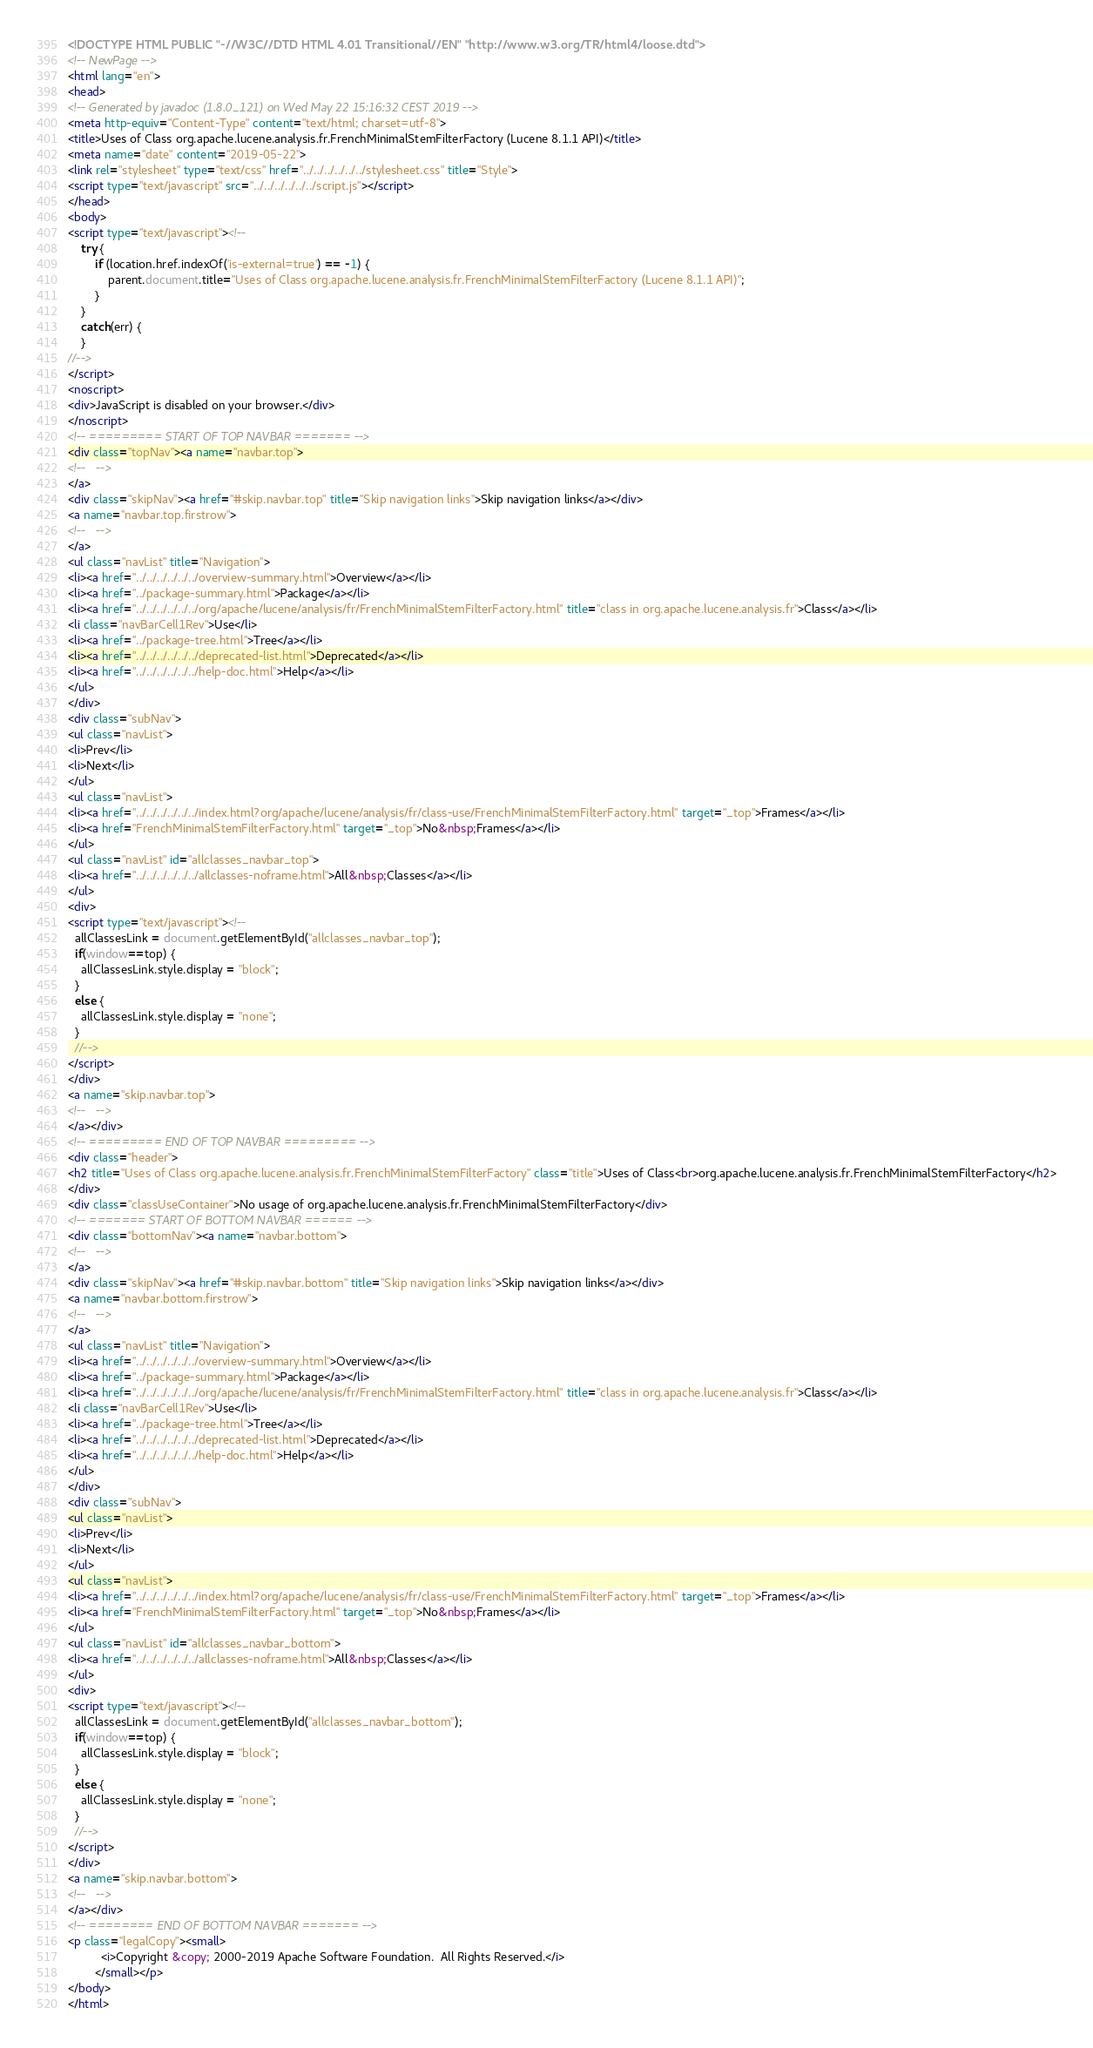<code> <loc_0><loc_0><loc_500><loc_500><_HTML_><!DOCTYPE HTML PUBLIC "-//W3C//DTD HTML 4.01 Transitional//EN" "http://www.w3.org/TR/html4/loose.dtd">
<!-- NewPage -->
<html lang="en">
<head>
<!-- Generated by javadoc (1.8.0_121) on Wed May 22 15:16:32 CEST 2019 -->
<meta http-equiv="Content-Type" content="text/html; charset=utf-8">
<title>Uses of Class org.apache.lucene.analysis.fr.FrenchMinimalStemFilterFactory (Lucene 8.1.1 API)</title>
<meta name="date" content="2019-05-22">
<link rel="stylesheet" type="text/css" href="../../../../../../stylesheet.css" title="Style">
<script type="text/javascript" src="../../../../../../script.js"></script>
</head>
<body>
<script type="text/javascript"><!--
    try {
        if (location.href.indexOf('is-external=true') == -1) {
            parent.document.title="Uses of Class org.apache.lucene.analysis.fr.FrenchMinimalStemFilterFactory (Lucene 8.1.1 API)";
        }
    }
    catch(err) {
    }
//-->
</script>
<noscript>
<div>JavaScript is disabled on your browser.</div>
</noscript>
<!-- ========= START OF TOP NAVBAR ======= -->
<div class="topNav"><a name="navbar.top">
<!--   -->
</a>
<div class="skipNav"><a href="#skip.navbar.top" title="Skip navigation links">Skip navigation links</a></div>
<a name="navbar.top.firstrow">
<!--   -->
</a>
<ul class="navList" title="Navigation">
<li><a href="../../../../../../overview-summary.html">Overview</a></li>
<li><a href="../package-summary.html">Package</a></li>
<li><a href="../../../../../../org/apache/lucene/analysis/fr/FrenchMinimalStemFilterFactory.html" title="class in org.apache.lucene.analysis.fr">Class</a></li>
<li class="navBarCell1Rev">Use</li>
<li><a href="../package-tree.html">Tree</a></li>
<li><a href="../../../../../../deprecated-list.html">Deprecated</a></li>
<li><a href="../../../../../../help-doc.html">Help</a></li>
</ul>
</div>
<div class="subNav">
<ul class="navList">
<li>Prev</li>
<li>Next</li>
</ul>
<ul class="navList">
<li><a href="../../../../../../index.html?org/apache/lucene/analysis/fr/class-use/FrenchMinimalStemFilterFactory.html" target="_top">Frames</a></li>
<li><a href="FrenchMinimalStemFilterFactory.html" target="_top">No&nbsp;Frames</a></li>
</ul>
<ul class="navList" id="allclasses_navbar_top">
<li><a href="../../../../../../allclasses-noframe.html">All&nbsp;Classes</a></li>
</ul>
<div>
<script type="text/javascript"><!--
  allClassesLink = document.getElementById("allclasses_navbar_top");
  if(window==top) {
    allClassesLink.style.display = "block";
  }
  else {
    allClassesLink.style.display = "none";
  }
  //-->
</script>
</div>
<a name="skip.navbar.top">
<!--   -->
</a></div>
<!-- ========= END OF TOP NAVBAR ========= -->
<div class="header">
<h2 title="Uses of Class org.apache.lucene.analysis.fr.FrenchMinimalStemFilterFactory" class="title">Uses of Class<br>org.apache.lucene.analysis.fr.FrenchMinimalStemFilterFactory</h2>
</div>
<div class="classUseContainer">No usage of org.apache.lucene.analysis.fr.FrenchMinimalStemFilterFactory</div>
<!-- ======= START OF BOTTOM NAVBAR ====== -->
<div class="bottomNav"><a name="navbar.bottom">
<!--   -->
</a>
<div class="skipNav"><a href="#skip.navbar.bottom" title="Skip navigation links">Skip navigation links</a></div>
<a name="navbar.bottom.firstrow">
<!--   -->
</a>
<ul class="navList" title="Navigation">
<li><a href="../../../../../../overview-summary.html">Overview</a></li>
<li><a href="../package-summary.html">Package</a></li>
<li><a href="../../../../../../org/apache/lucene/analysis/fr/FrenchMinimalStemFilterFactory.html" title="class in org.apache.lucene.analysis.fr">Class</a></li>
<li class="navBarCell1Rev">Use</li>
<li><a href="../package-tree.html">Tree</a></li>
<li><a href="../../../../../../deprecated-list.html">Deprecated</a></li>
<li><a href="../../../../../../help-doc.html">Help</a></li>
</ul>
</div>
<div class="subNav">
<ul class="navList">
<li>Prev</li>
<li>Next</li>
</ul>
<ul class="navList">
<li><a href="../../../../../../index.html?org/apache/lucene/analysis/fr/class-use/FrenchMinimalStemFilterFactory.html" target="_top">Frames</a></li>
<li><a href="FrenchMinimalStemFilterFactory.html" target="_top">No&nbsp;Frames</a></li>
</ul>
<ul class="navList" id="allclasses_navbar_bottom">
<li><a href="../../../../../../allclasses-noframe.html">All&nbsp;Classes</a></li>
</ul>
<div>
<script type="text/javascript"><!--
  allClassesLink = document.getElementById("allclasses_navbar_bottom");
  if(window==top) {
    allClassesLink.style.display = "block";
  }
  else {
    allClassesLink.style.display = "none";
  }
  //-->
</script>
</div>
<a name="skip.navbar.bottom">
<!--   -->
</a></div>
<!-- ======== END OF BOTTOM NAVBAR ======= -->
<p class="legalCopy"><small>
          <i>Copyright &copy; 2000-2019 Apache Software Foundation.  All Rights Reserved.</i>
        </small></p>
</body>
</html>
</code> 